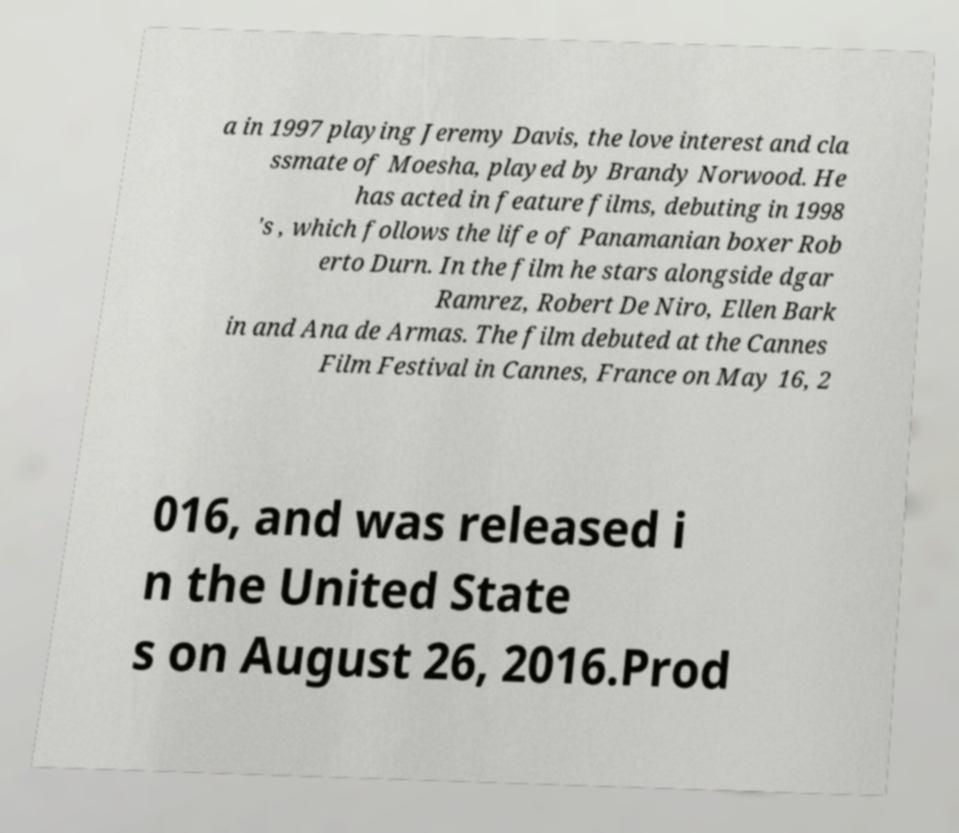What messages or text are displayed in this image? I need them in a readable, typed format. a in 1997 playing Jeremy Davis, the love interest and cla ssmate of Moesha, played by Brandy Norwood. He has acted in feature films, debuting in 1998 's , which follows the life of Panamanian boxer Rob erto Durn. In the film he stars alongside dgar Ramrez, Robert De Niro, Ellen Bark in and Ana de Armas. The film debuted at the Cannes Film Festival in Cannes, France on May 16, 2 016, and was released i n the United State s on August 26, 2016.Prod 